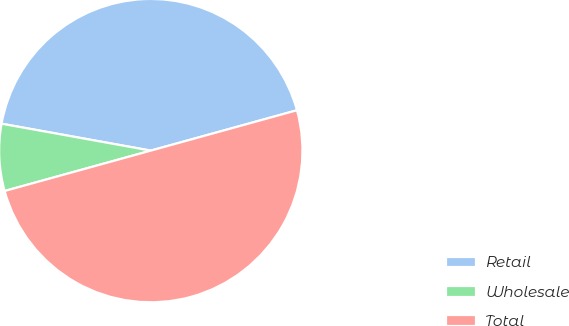Convert chart. <chart><loc_0><loc_0><loc_500><loc_500><pie_chart><fcel>Retail<fcel>Wholesale<fcel>Total<nl><fcel>42.87%<fcel>7.13%<fcel>50.0%<nl></chart> 